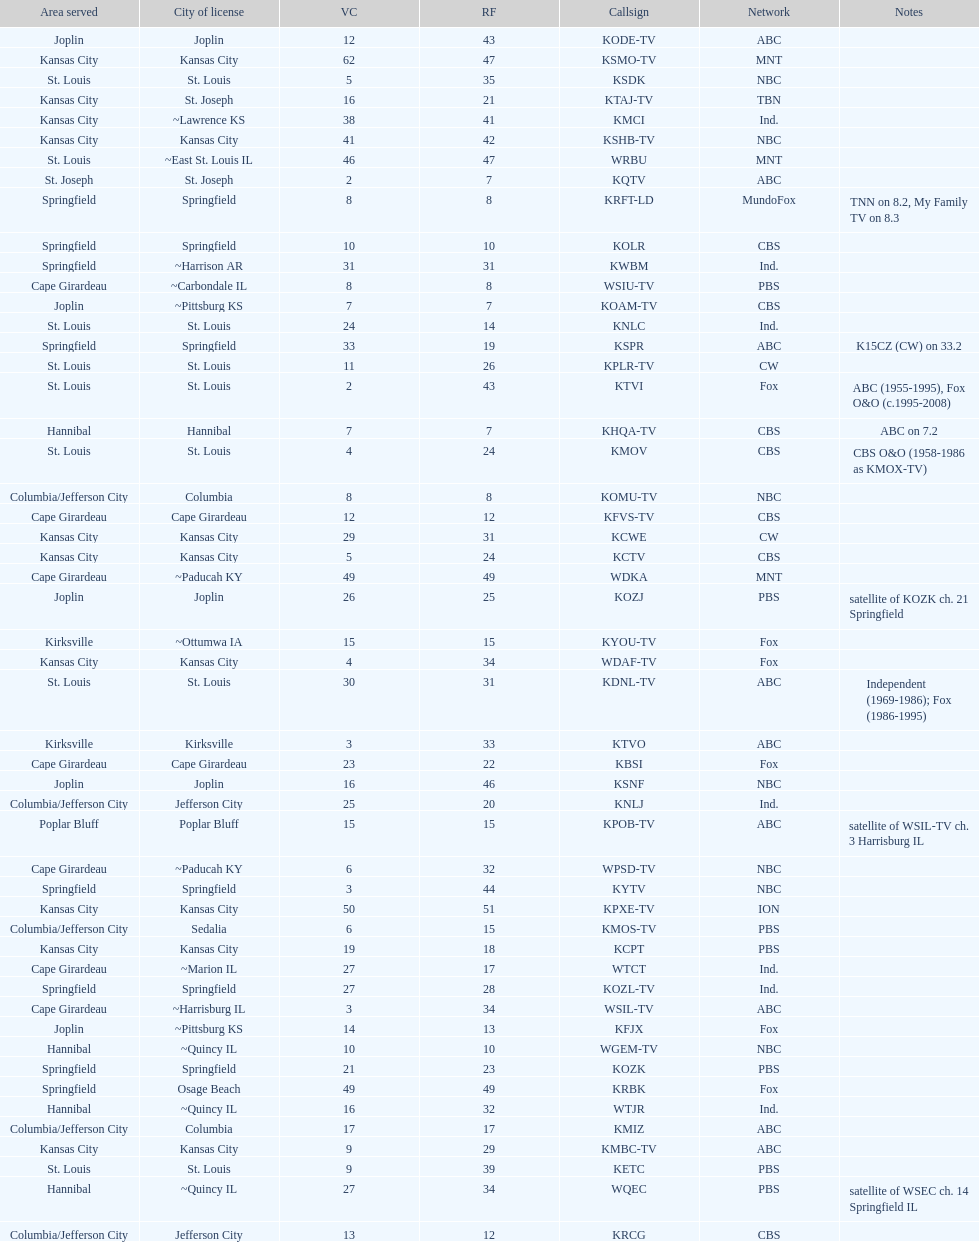How many are on the cbs network? 7. 